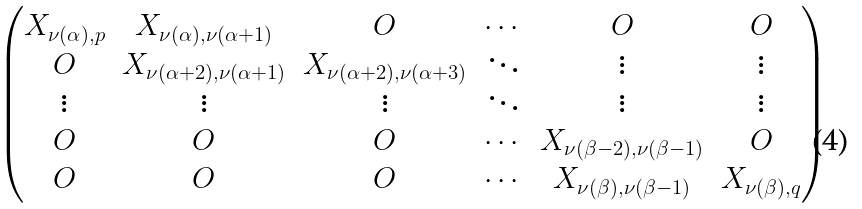<formula> <loc_0><loc_0><loc_500><loc_500>\begin{pmatrix} X _ { \nu ( \alpha ) , p } & X _ { \nu ( \alpha ) , \nu ( \alpha + 1 ) } & O & \cdots & O & O \\ O & X _ { \nu ( \alpha + 2 ) , \nu ( \alpha + 1 ) } & X _ { \nu ( \alpha + 2 ) , \nu ( \alpha + 3 ) } & \ddots & \vdots & \vdots \\ \vdots & \vdots & \vdots & \ddots & \vdots & \vdots \\ O & O & O & \cdots & X _ { \nu ( \beta - 2 ) , \nu ( \beta - 1 ) } & O \\ O & O & O & \cdots & X _ { \nu ( \beta ) , \nu ( \beta - 1 ) } & X _ { \nu ( \beta ) , q } \end{pmatrix}</formula> 